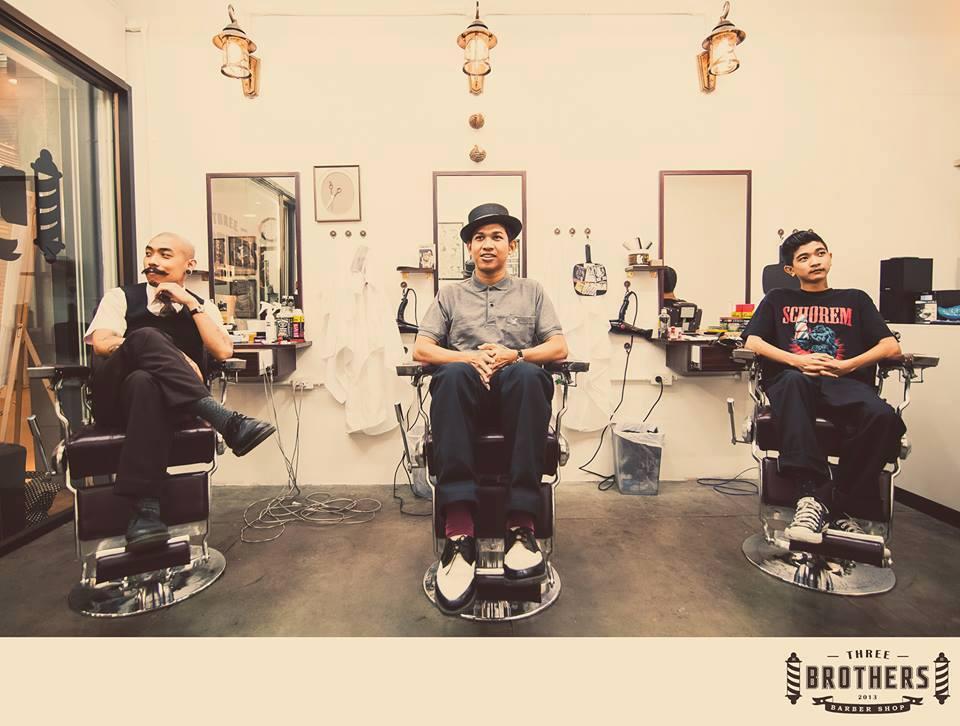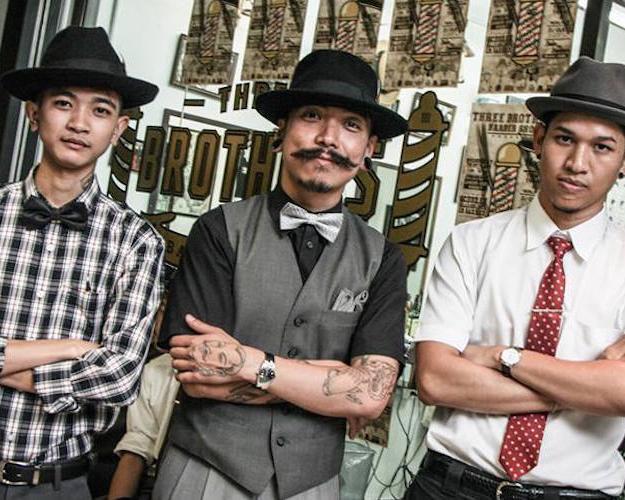The first image is the image on the left, the second image is the image on the right. Analyze the images presented: Is the assertion "In one image three men are sitting in barber chairs, one of them bald, one wearing a hat, and one with hair and no hat." valid? Answer yes or no. Yes. The first image is the image on the left, the second image is the image on the right. For the images displayed, is the sentence "Three men are sitting in barber chairs in one of the images." factually correct? Answer yes or no. Yes. 